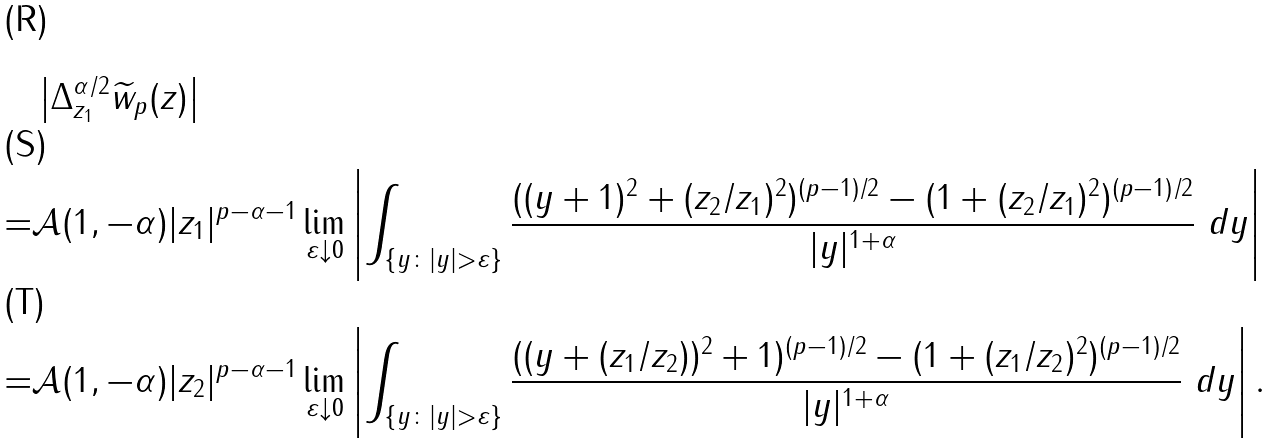Convert formula to latex. <formula><loc_0><loc_0><loc_500><loc_500>& \left | \Delta _ { z _ { 1 } } ^ { \alpha / 2 } \widetilde { w } _ { p } ( z ) \right | \\ = & \mathcal { A } ( 1 , - \alpha ) | z _ { 1 } | ^ { p - \alpha - 1 } \lim _ { \varepsilon \downarrow 0 } \left | \int _ { \{ y \colon | y | > \varepsilon \} } \frac { ( ( y + 1 ) ^ { 2 } + ( z _ { 2 } / z _ { 1 } ) ^ { 2 } ) ^ { ( p - 1 ) / 2 } - ( 1 + ( z _ { 2 } / z _ { 1 } ) ^ { 2 } ) ^ { ( p - 1 ) / 2 } } { | y | ^ { 1 + \alpha } } \ d y \right | \\ = & \mathcal { A } ( 1 , - \alpha ) | z _ { 2 } | ^ { p - \alpha - 1 } \lim _ { \varepsilon \downarrow 0 } \left | \int _ { \{ y \colon | y | > \varepsilon \} } \frac { ( ( y + ( z _ { 1 } / z _ { 2 } ) ) ^ { 2 } + 1 ) ^ { ( p - 1 ) / 2 } - ( 1 + ( z _ { 1 } / z _ { 2 } ) ^ { 2 } ) ^ { ( p - 1 ) / 2 } } { | y | ^ { 1 + \alpha } } \ d y \right | .</formula> 